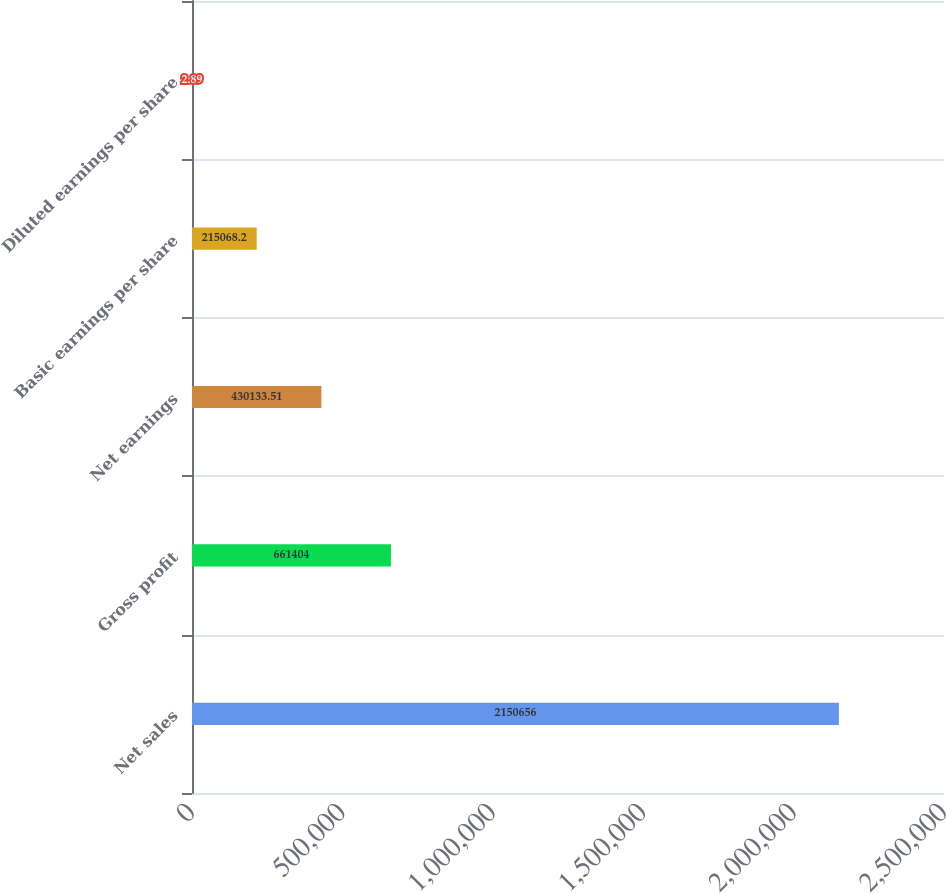Convert chart to OTSL. <chart><loc_0><loc_0><loc_500><loc_500><bar_chart><fcel>Net sales<fcel>Gross profit<fcel>Net earnings<fcel>Basic earnings per share<fcel>Diluted earnings per share<nl><fcel>2.15066e+06<fcel>661404<fcel>430134<fcel>215068<fcel>2.89<nl></chart> 